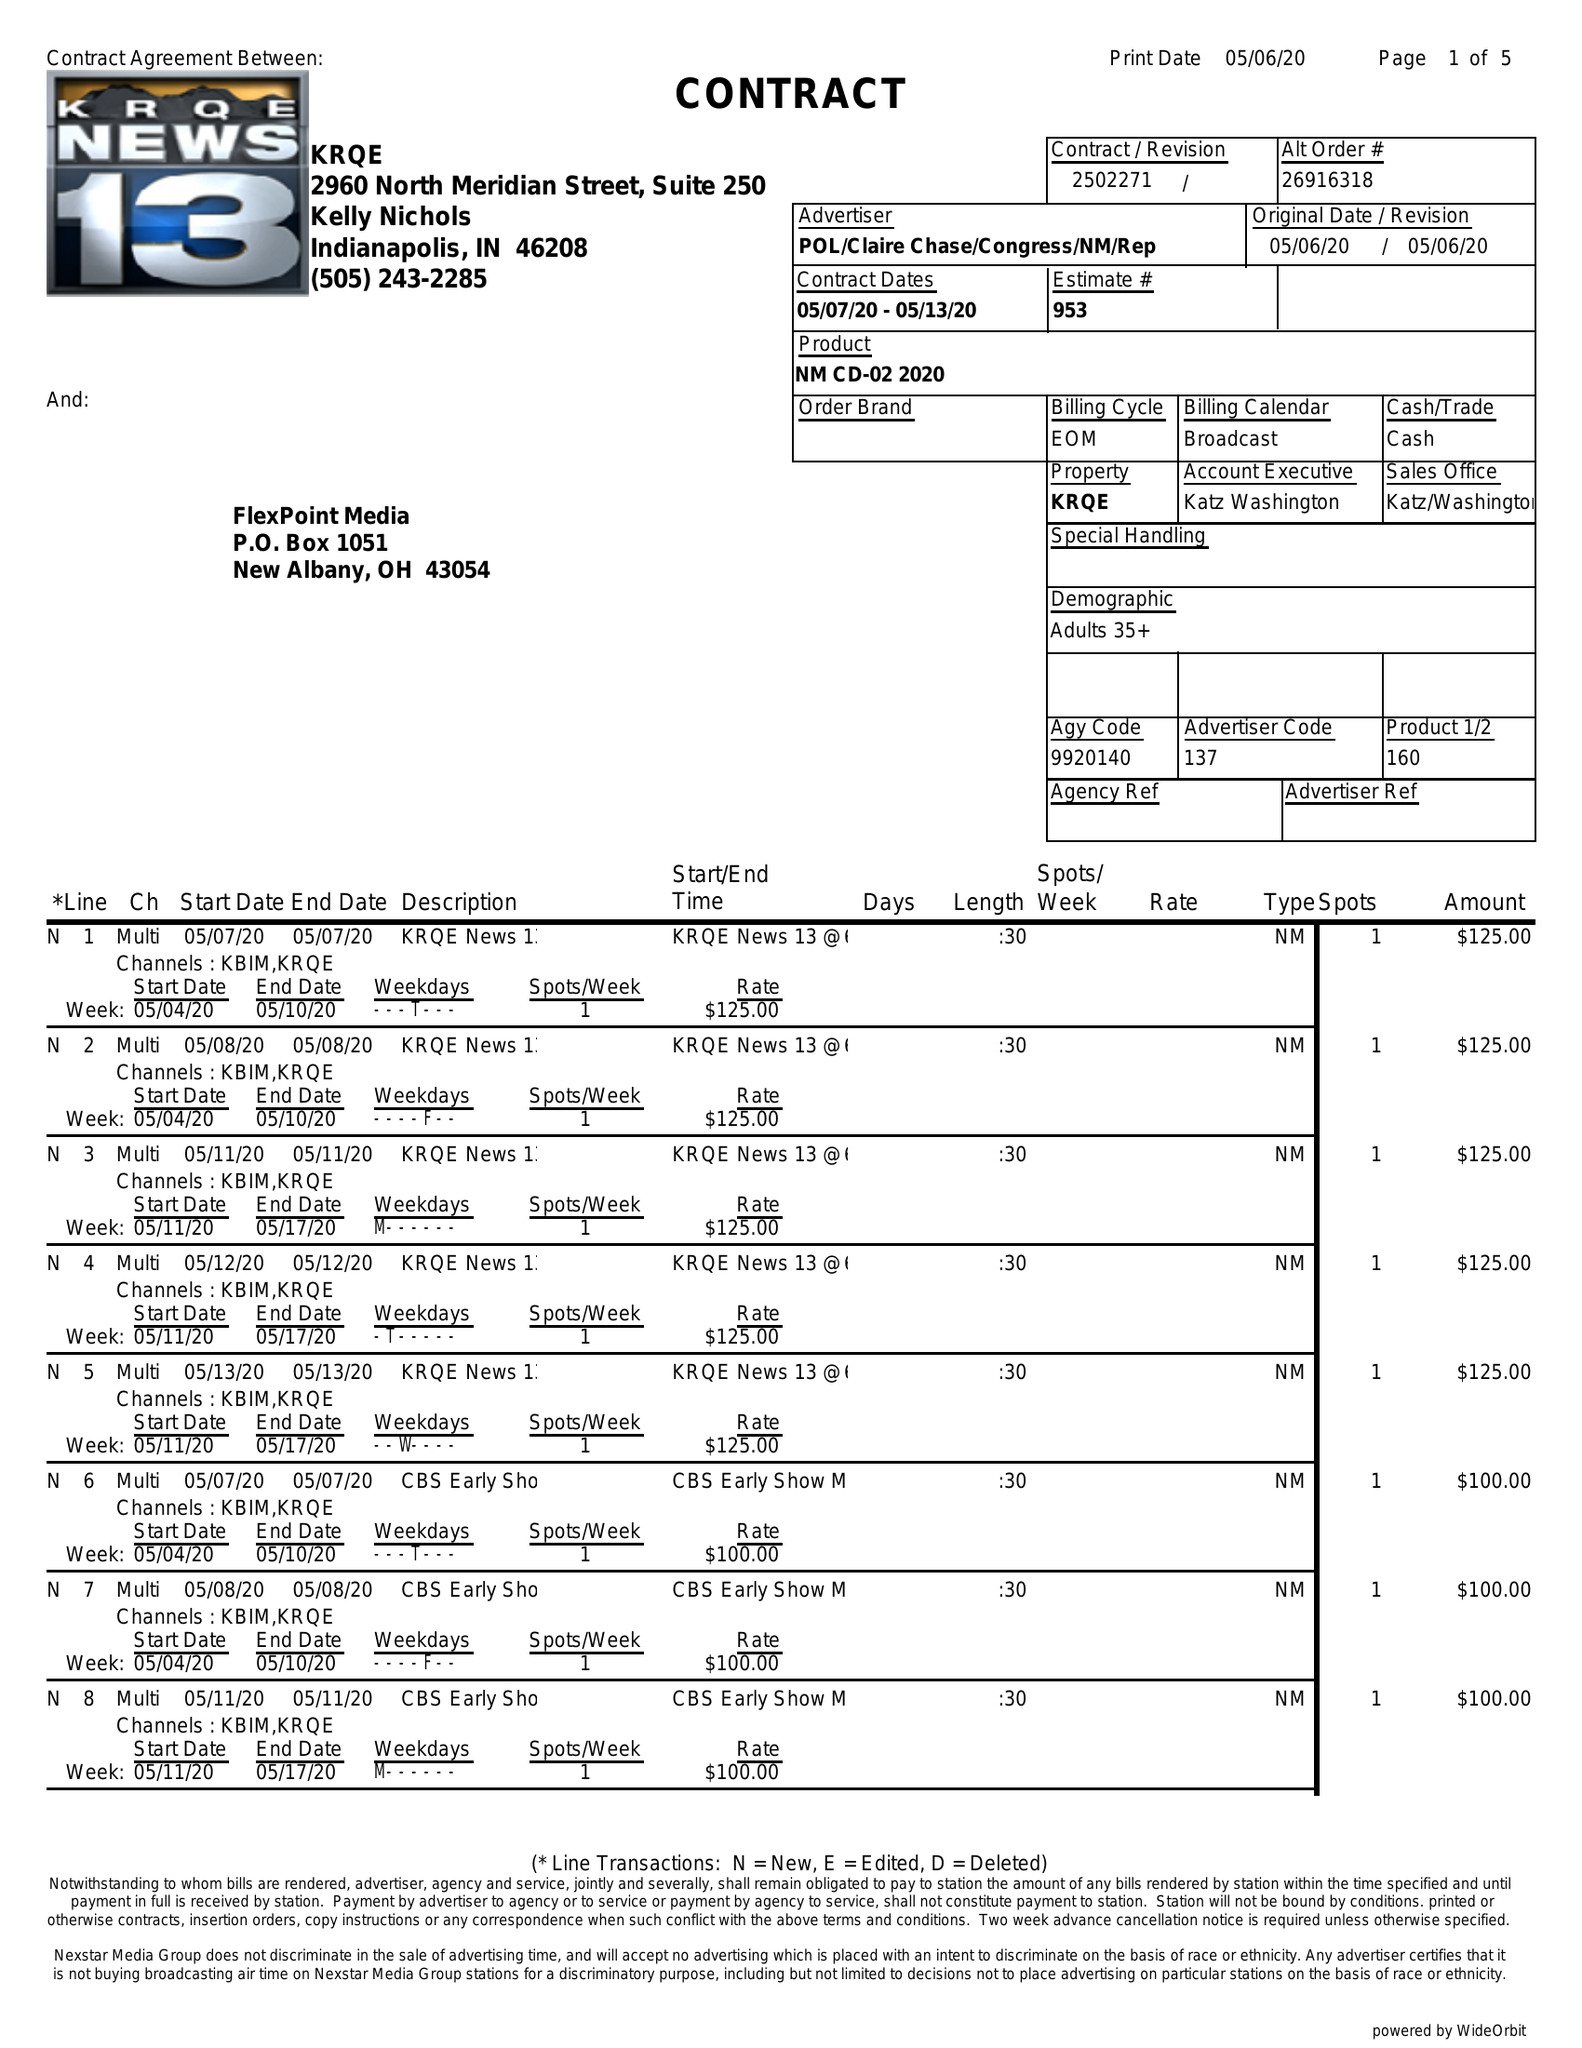What is the value for the flight_from?
Answer the question using a single word or phrase. 05/07/20 